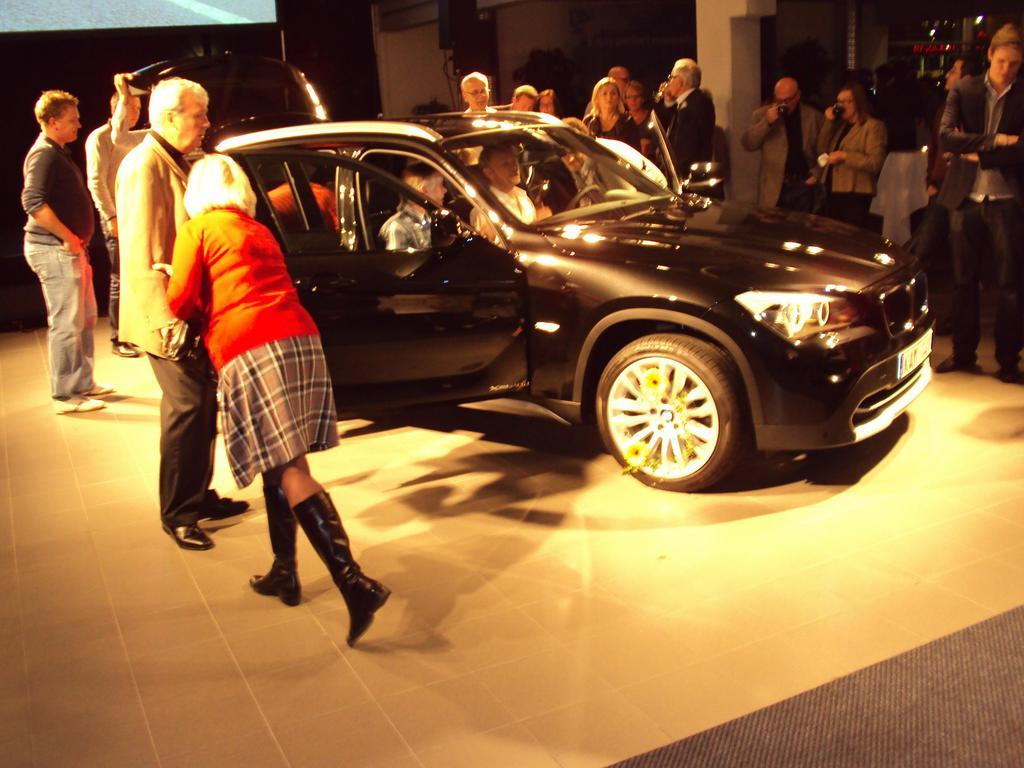What is the main subject of the image? The main subject of the image is a car. What are the people in the image doing? There are people standing around the car and some are sitting in the car. What type of wood is used to make the vase on the car's dashboard? There is no vase present on the car's dashboard in the image, so it is not possible to determine the type of wood used. 